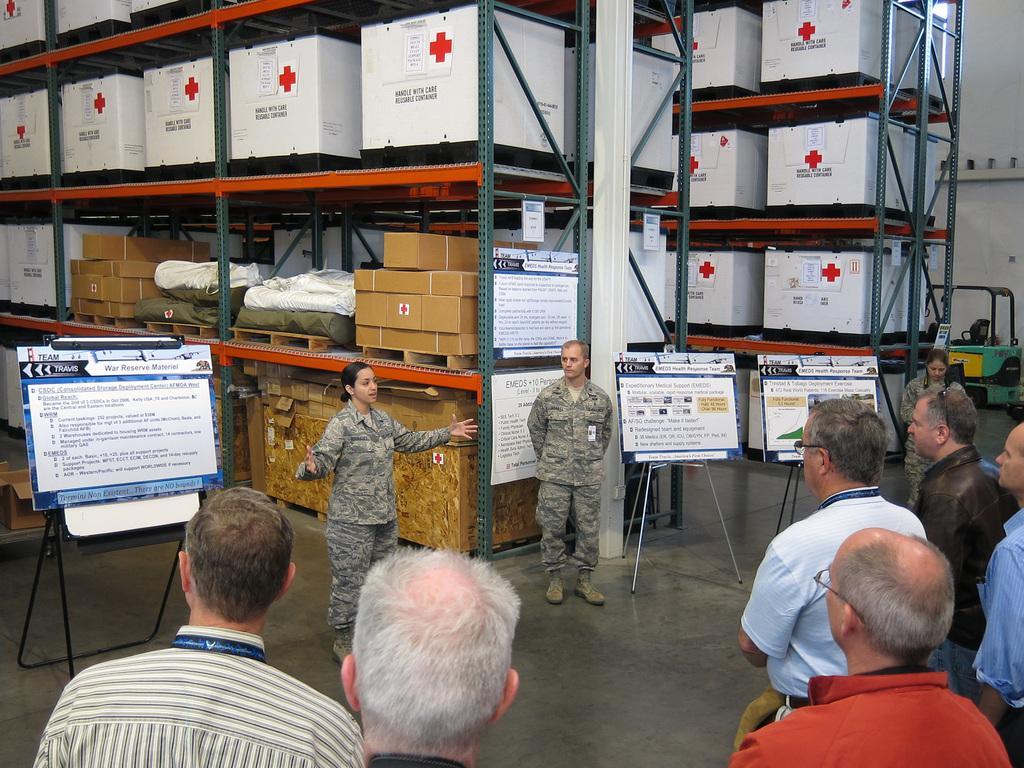In one or two sentences, can you explain what this image depicts? In this image we a few people, there are some stands, boards with some text written on it, there are some boxes, medical kits, and packages on the tracks, we can see pillar, vehicle, and the wall. 